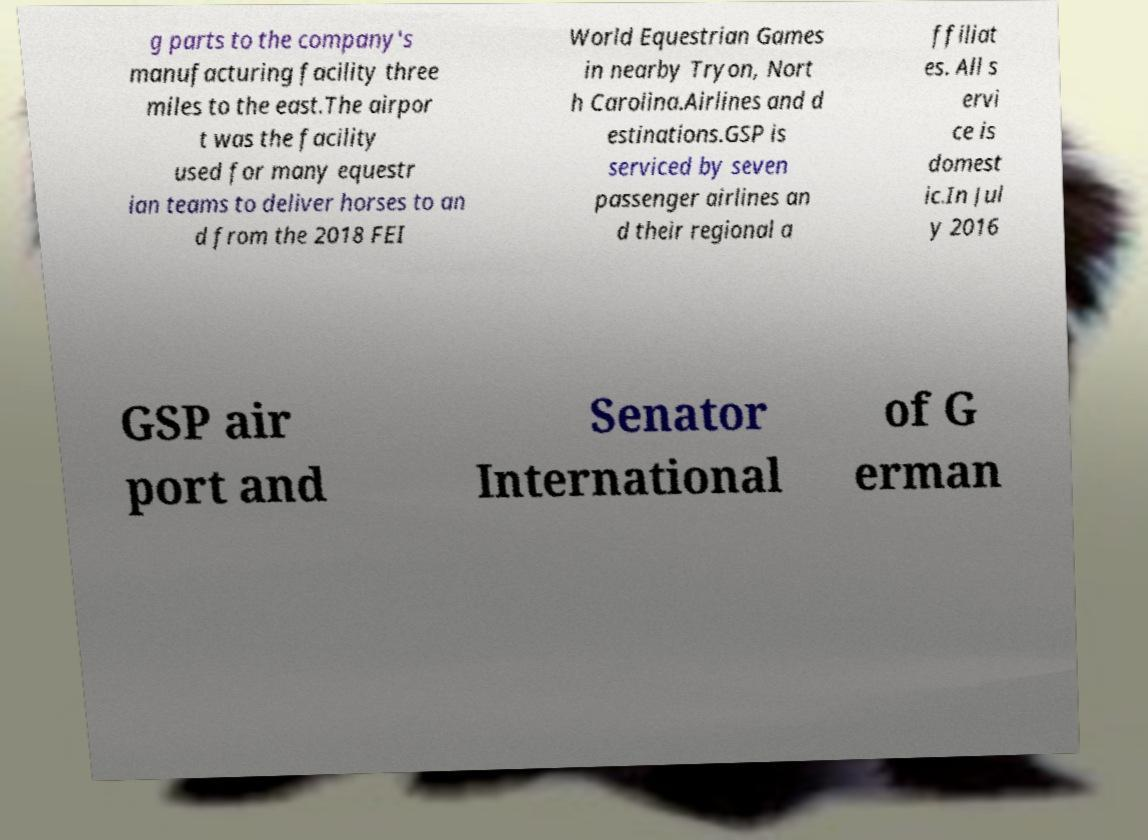Could you extract and type out the text from this image? g parts to the company's manufacturing facility three miles to the east.The airpor t was the facility used for many equestr ian teams to deliver horses to an d from the 2018 FEI World Equestrian Games in nearby Tryon, Nort h Carolina.Airlines and d estinations.GSP is serviced by seven passenger airlines an d their regional a ffiliat es. All s ervi ce is domest ic.In Jul y 2016 GSP air port and Senator International of G erman 